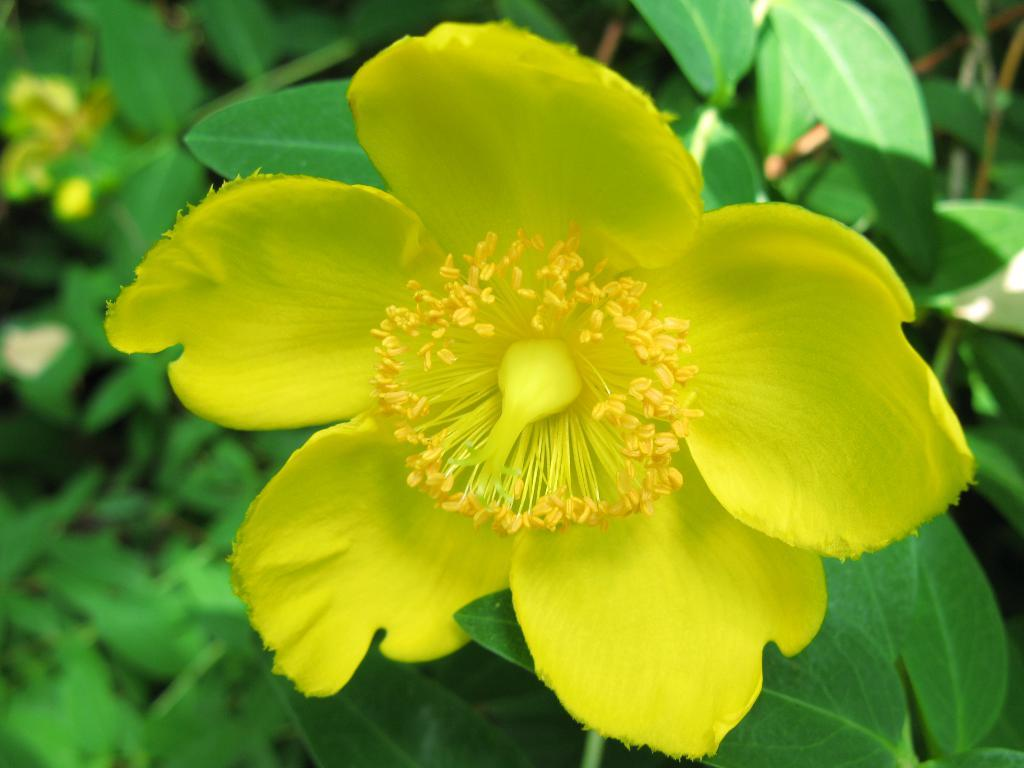What type of flower is in the image? There is a yellow flower in the image. How is the flower described? The flower is described as beautiful. What color are the leaves of the flower? The flower has green leaves. What type of coal can be seen in the image? There is no coal present in the image; it features a yellow flower with green leaves. How is the milk being used in the image? There is no milk present in the image; it only features a yellow flower with green leaves. 